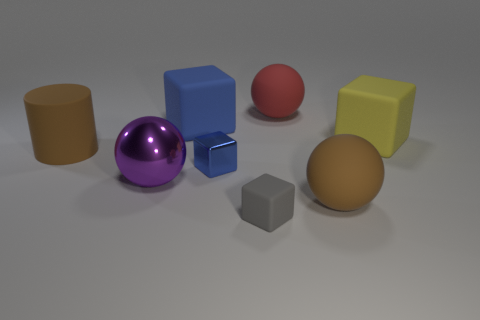Add 2 small green cylinders. How many objects exist? 10 Subtract all balls. How many objects are left? 5 Add 5 small blocks. How many small blocks exist? 7 Subtract 1 blue blocks. How many objects are left? 7 Subtract all yellow objects. Subtract all large shiny balls. How many objects are left? 6 Add 3 tiny metal objects. How many tiny metal objects are left? 4 